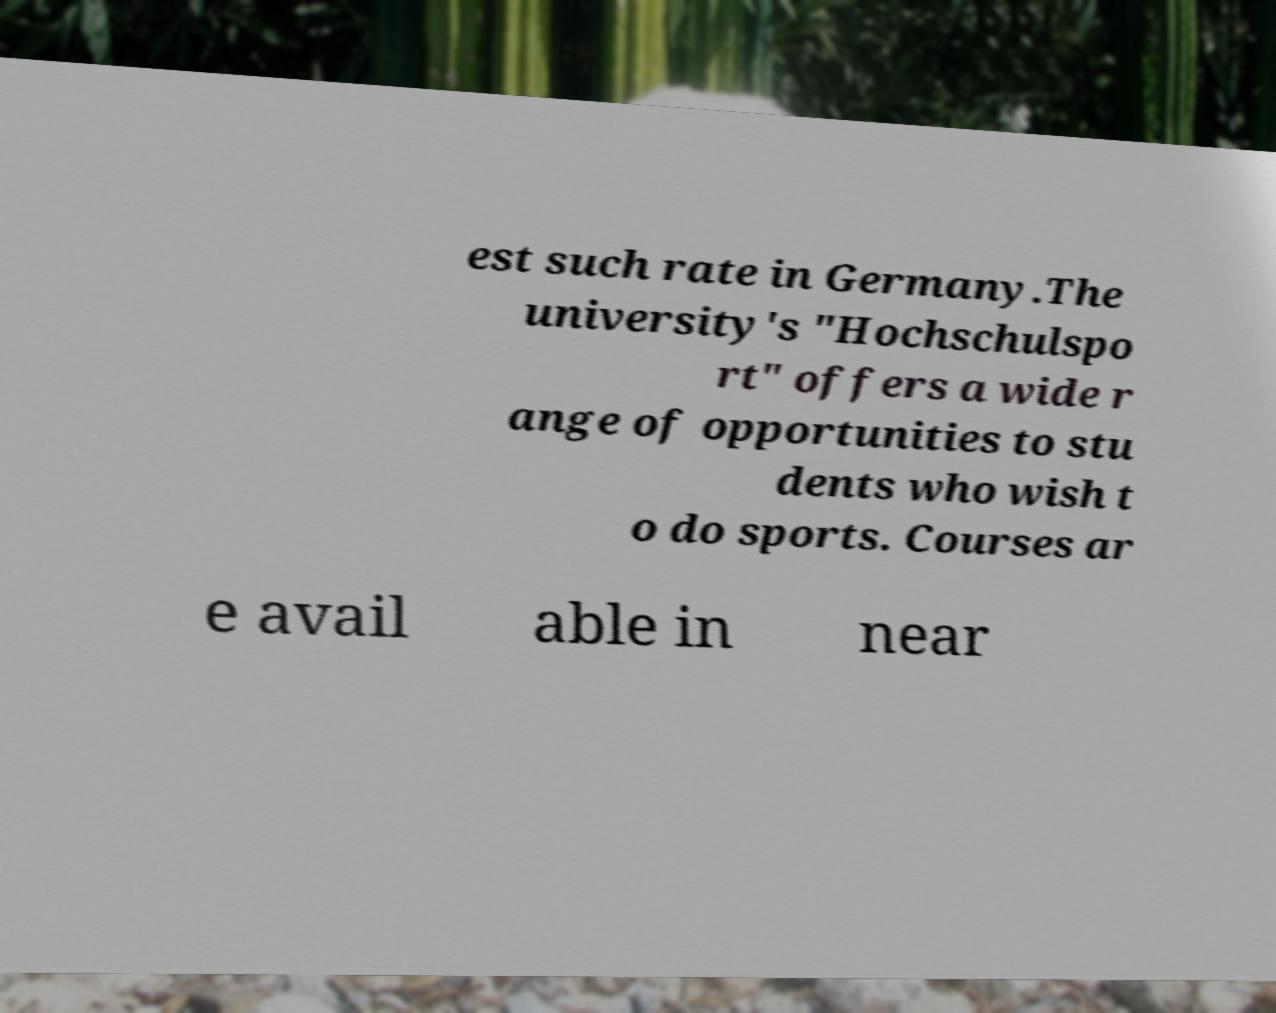Can you read and provide the text displayed in the image?This photo seems to have some interesting text. Can you extract and type it out for me? est such rate in Germany.The university's "Hochschulspo rt" offers a wide r ange of opportunities to stu dents who wish t o do sports. Courses ar e avail able in near 